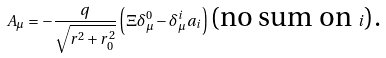<formula> <loc_0><loc_0><loc_500><loc_500>A _ { \mu } = - \frac { q } { \sqrt { r ^ { 2 } + r _ { 0 } ^ { 2 } } } \left ( \Xi \delta _ { \mu } ^ { 0 } - \delta _ { \mu } ^ { i } a _ { i } \right ) \text {(no sum on } i \text {).}</formula> 